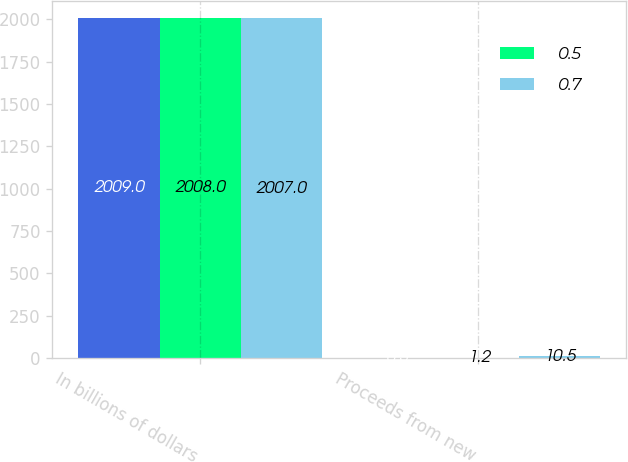<chart> <loc_0><loc_0><loc_500><loc_500><stacked_bar_chart><ecel><fcel>In billions of dollars<fcel>Proceeds from new<nl><fcel>nan<fcel>2009<fcel>0.3<nl><fcel>0.5<fcel>2008<fcel>1.2<nl><fcel>0.7<fcel>2007<fcel>10.5<nl></chart> 